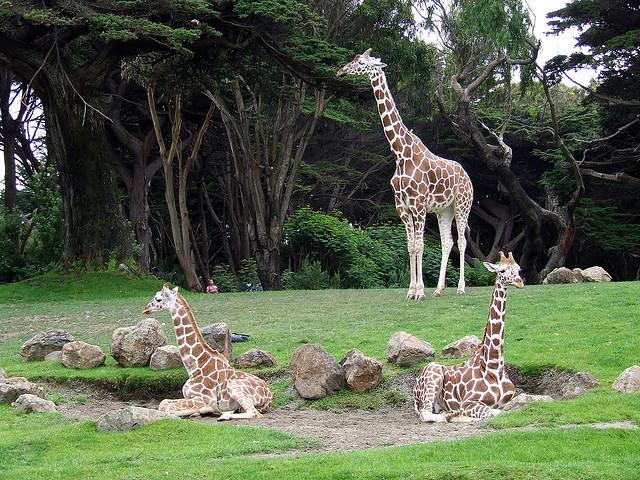Is this their natural habitat?
Write a very short answer. Yes. How many giraffes are sitting?
Short answer required. 2. What are the majority of the giraffes doing?
Give a very brief answer. Sitting. 